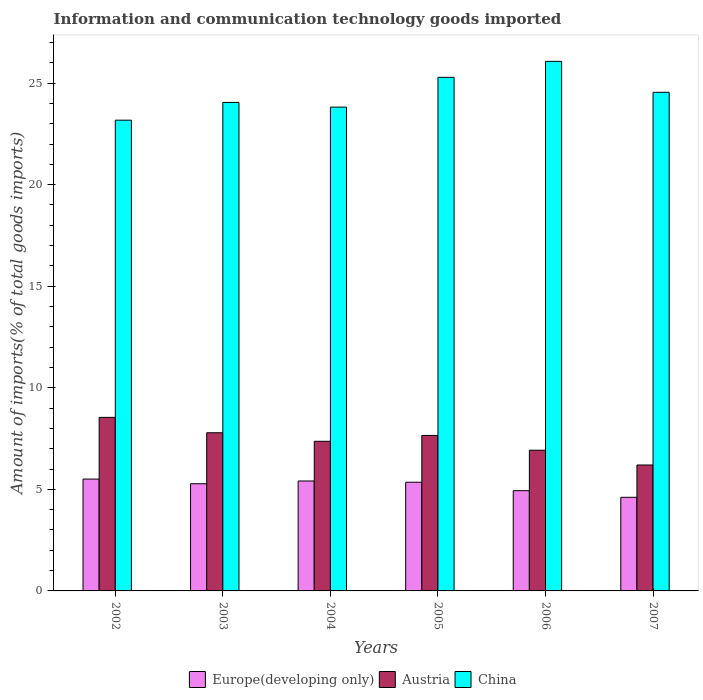How many different coloured bars are there?
Your answer should be compact. 3. How many groups of bars are there?
Your response must be concise. 6. In how many cases, is the number of bars for a given year not equal to the number of legend labels?
Offer a very short reply. 0. What is the amount of goods imported in China in 2006?
Give a very brief answer. 26.07. Across all years, what is the maximum amount of goods imported in Austria?
Offer a terse response. 8.54. Across all years, what is the minimum amount of goods imported in China?
Give a very brief answer. 23.17. In which year was the amount of goods imported in Austria maximum?
Offer a very short reply. 2002. What is the total amount of goods imported in Europe(developing only) in the graph?
Offer a very short reply. 31.09. What is the difference between the amount of goods imported in Austria in 2002 and that in 2005?
Provide a short and direct response. 0.89. What is the difference between the amount of goods imported in Austria in 2006 and the amount of goods imported in Europe(developing only) in 2004?
Your response must be concise. 1.51. What is the average amount of goods imported in China per year?
Your answer should be compact. 24.49. In the year 2005, what is the difference between the amount of goods imported in Austria and amount of goods imported in Europe(developing only)?
Offer a very short reply. 2.3. What is the ratio of the amount of goods imported in China in 2002 to that in 2007?
Keep it short and to the point. 0.94. Is the amount of goods imported in China in 2004 less than that in 2005?
Provide a succinct answer. Yes. What is the difference between the highest and the second highest amount of goods imported in Europe(developing only)?
Give a very brief answer. 0.09. What is the difference between the highest and the lowest amount of goods imported in China?
Make the answer very short. 2.9. Is the sum of the amount of goods imported in China in 2003 and 2004 greater than the maximum amount of goods imported in Austria across all years?
Offer a terse response. Yes. What does the 3rd bar from the left in 2005 represents?
Give a very brief answer. China. How many bars are there?
Provide a short and direct response. 18. Where does the legend appear in the graph?
Provide a succinct answer. Bottom center. How many legend labels are there?
Your answer should be compact. 3. How are the legend labels stacked?
Keep it short and to the point. Horizontal. What is the title of the graph?
Give a very brief answer. Information and communication technology goods imported. What is the label or title of the Y-axis?
Your answer should be very brief. Amount of imports(% of total goods imports). What is the Amount of imports(% of total goods imports) in Europe(developing only) in 2002?
Provide a succinct answer. 5.51. What is the Amount of imports(% of total goods imports) in Austria in 2002?
Offer a very short reply. 8.54. What is the Amount of imports(% of total goods imports) of China in 2002?
Keep it short and to the point. 23.17. What is the Amount of imports(% of total goods imports) of Europe(developing only) in 2003?
Provide a succinct answer. 5.28. What is the Amount of imports(% of total goods imports) in Austria in 2003?
Offer a very short reply. 7.79. What is the Amount of imports(% of total goods imports) in China in 2003?
Provide a short and direct response. 24.05. What is the Amount of imports(% of total goods imports) in Europe(developing only) in 2004?
Provide a short and direct response. 5.41. What is the Amount of imports(% of total goods imports) of Austria in 2004?
Make the answer very short. 7.37. What is the Amount of imports(% of total goods imports) in China in 2004?
Your answer should be compact. 23.82. What is the Amount of imports(% of total goods imports) in Europe(developing only) in 2005?
Make the answer very short. 5.35. What is the Amount of imports(% of total goods imports) in Austria in 2005?
Your answer should be compact. 7.65. What is the Amount of imports(% of total goods imports) in China in 2005?
Ensure brevity in your answer.  25.28. What is the Amount of imports(% of total goods imports) in Europe(developing only) in 2006?
Provide a short and direct response. 4.93. What is the Amount of imports(% of total goods imports) of Austria in 2006?
Offer a terse response. 6.93. What is the Amount of imports(% of total goods imports) of China in 2006?
Make the answer very short. 26.07. What is the Amount of imports(% of total goods imports) in Europe(developing only) in 2007?
Ensure brevity in your answer.  4.61. What is the Amount of imports(% of total goods imports) in Austria in 2007?
Your response must be concise. 6.2. What is the Amount of imports(% of total goods imports) of China in 2007?
Provide a succinct answer. 24.55. Across all years, what is the maximum Amount of imports(% of total goods imports) of Europe(developing only)?
Your response must be concise. 5.51. Across all years, what is the maximum Amount of imports(% of total goods imports) of Austria?
Ensure brevity in your answer.  8.54. Across all years, what is the maximum Amount of imports(% of total goods imports) of China?
Provide a short and direct response. 26.07. Across all years, what is the minimum Amount of imports(% of total goods imports) of Europe(developing only)?
Your response must be concise. 4.61. Across all years, what is the minimum Amount of imports(% of total goods imports) of Austria?
Keep it short and to the point. 6.2. Across all years, what is the minimum Amount of imports(% of total goods imports) of China?
Your answer should be compact. 23.17. What is the total Amount of imports(% of total goods imports) of Europe(developing only) in the graph?
Your answer should be compact. 31.09. What is the total Amount of imports(% of total goods imports) of Austria in the graph?
Provide a short and direct response. 44.47. What is the total Amount of imports(% of total goods imports) of China in the graph?
Keep it short and to the point. 146.93. What is the difference between the Amount of imports(% of total goods imports) in Europe(developing only) in 2002 and that in 2003?
Offer a terse response. 0.23. What is the difference between the Amount of imports(% of total goods imports) in Austria in 2002 and that in 2003?
Give a very brief answer. 0.76. What is the difference between the Amount of imports(% of total goods imports) of China in 2002 and that in 2003?
Give a very brief answer. -0.87. What is the difference between the Amount of imports(% of total goods imports) in Europe(developing only) in 2002 and that in 2004?
Offer a very short reply. 0.09. What is the difference between the Amount of imports(% of total goods imports) in Austria in 2002 and that in 2004?
Make the answer very short. 1.18. What is the difference between the Amount of imports(% of total goods imports) of China in 2002 and that in 2004?
Make the answer very short. -0.64. What is the difference between the Amount of imports(% of total goods imports) of Europe(developing only) in 2002 and that in 2005?
Keep it short and to the point. 0.16. What is the difference between the Amount of imports(% of total goods imports) in Austria in 2002 and that in 2005?
Provide a short and direct response. 0.89. What is the difference between the Amount of imports(% of total goods imports) of China in 2002 and that in 2005?
Offer a very short reply. -2.11. What is the difference between the Amount of imports(% of total goods imports) of Europe(developing only) in 2002 and that in 2006?
Give a very brief answer. 0.57. What is the difference between the Amount of imports(% of total goods imports) in Austria in 2002 and that in 2006?
Your answer should be compact. 1.62. What is the difference between the Amount of imports(% of total goods imports) in China in 2002 and that in 2006?
Offer a terse response. -2.9. What is the difference between the Amount of imports(% of total goods imports) in Europe(developing only) in 2002 and that in 2007?
Offer a terse response. 0.9. What is the difference between the Amount of imports(% of total goods imports) in Austria in 2002 and that in 2007?
Offer a terse response. 2.34. What is the difference between the Amount of imports(% of total goods imports) in China in 2002 and that in 2007?
Make the answer very short. -1.37. What is the difference between the Amount of imports(% of total goods imports) in Europe(developing only) in 2003 and that in 2004?
Offer a terse response. -0.14. What is the difference between the Amount of imports(% of total goods imports) in Austria in 2003 and that in 2004?
Keep it short and to the point. 0.42. What is the difference between the Amount of imports(% of total goods imports) in China in 2003 and that in 2004?
Offer a terse response. 0.23. What is the difference between the Amount of imports(% of total goods imports) of Europe(developing only) in 2003 and that in 2005?
Offer a terse response. -0.07. What is the difference between the Amount of imports(% of total goods imports) in Austria in 2003 and that in 2005?
Offer a very short reply. 0.13. What is the difference between the Amount of imports(% of total goods imports) in China in 2003 and that in 2005?
Keep it short and to the point. -1.24. What is the difference between the Amount of imports(% of total goods imports) of Europe(developing only) in 2003 and that in 2006?
Make the answer very short. 0.34. What is the difference between the Amount of imports(% of total goods imports) of Austria in 2003 and that in 2006?
Ensure brevity in your answer.  0.86. What is the difference between the Amount of imports(% of total goods imports) in China in 2003 and that in 2006?
Provide a succinct answer. -2.02. What is the difference between the Amount of imports(% of total goods imports) of Europe(developing only) in 2003 and that in 2007?
Offer a terse response. 0.67. What is the difference between the Amount of imports(% of total goods imports) of Austria in 2003 and that in 2007?
Your answer should be compact. 1.59. What is the difference between the Amount of imports(% of total goods imports) in China in 2003 and that in 2007?
Provide a short and direct response. -0.5. What is the difference between the Amount of imports(% of total goods imports) in Europe(developing only) in 2004 and that in 2005?
Make the answer very short. 0.06. What is the difference between the Amount of imports(% of total goods imports) in Austria in 2004 and that in 2005?
Ensure brevity in your answer.  -0.29. What is the difference between the Amount of imports(% of total goods imports) in China in 2004 and that in 2005?
Your answer should be very brief. -1.47. What is the difference between the Amount of imports(% of total goods imports) of Europe(developing only) in 2004 and that in 2006?
Offer a terse response. 0.48. What is the difference between the Amount of imports(% of total goods imports) in Austria in 2004 and that in 2006?
Provide a succinct answer. 0.44. What is the difference between the Amount of imports(% of total goods imports) of China in 2004 and that in 2006?
Provide a succinct answer. -2.25. What is the difference between the Amount of imports(% of total goods imports) of Europe(developing only) in 2004 and that in 2007?
Your answer should be very brief. 0.8. What is the difference between the Amount of imports(% of total goods imports) of Austria in 2004 and that in 2007?
Offer a very short reply. 1.17. What is the difference between the Amount of imports(% of total goods imports) of China in 2004 and that in 2007?
Ensure brevity in your answer.  -0.73. What is the difference between the Amount of imports(% of total goods imports) in Europe(developing only) in 2005 and that in 2006?
Your response must be concise. 0.42. What is the difference between the Amount of imports(% of total goods imports) of Austria in 2005 and that in 2006?
Provide a succinct answer. 0.73. What is the difference between the Amount of imports(% of total goods imports) of China in 2005 and that in 2006?
Your answer should be very brief. -0.79. What is the difference between the Amount of imports(% of total goods imports) in Europe(developing only) in 2005 and that in 2007?
Give a very brief answer. 0.74. What is the difference between the Amount of imports(% of total goods imports) of Austria in 2005 and that in 2007?
Your answer should be compact. 1.46. What is the difference between the Amount of imports(% of total goods imports) of China in 2005 and that in 2007?
Your answer should be compact. 0.74. What is the difference between the Amount of imports(% of total goods imports) of Europe(developing only) in 2006 and that in 2007?
Offer a very short reply. 0.33. What is the difference between the Amount of imports(% of total goods imports) in Austria in 2006 and that in 2007?
Your response must be concise. 0.73. What is the difference between the Amount of imports(% of total goods imports) in China in 2006 and that in 2007?
Offer a very short reply. 1.52. What is the difference between the Amount of imports(% of total goods imports) in Europe(developing only) in 2002 and the Amount of imports(% of total goods imports) in Austria in 2003?
Provide a succinct answer. -2.28. What is the difference between the Amount of imports(% of total goods imports) of Europe(developing only) in 2002 and the Amount of imports(% of total goods imports) of China in 2003?
Ensure brevity in your answer.  -18.54. What is the difference between the Amount of imports(% of total goods imports) in Austria in 2002 and the Amount of imports(% of total goods imports) in China in 2003?
Give a very brief answer. -15.5. What is the difference between the Amount of imports(% of total goods imports) in Europe(developing only) in 2002 and the Amount of imports(% of total goods imports) in Austria in 2004?
Your answer should be very brief. -1.86. What is the difference between the Amount of imports(% of total goods imports) in Europe(developing only) in 2002 and the Amount of imports(% of total goods imports) in China in 2004?
Your answer should be very brief. -18.31. What is the difference between the Amount of imports(% of total goods imports) of Austria in 2002 and the Amount of imports(% of total goods imports) of China in 2004?
Keep it short and to the point. -15.27. What is the difference between the Amount of imports(% of total goods imports) in Europe(developing only) in 2002 and the Amount of imports(% of total goods imports) in Austria in 2005?
Your answer should be very brief. -2.15. What is the difference between the Amount of imports(% of total goods imports) in Europe(developing only) in 2002 and the Amount of imports(% of total goods imports) in China in 2005?
Provide a short and direct response. -19.78. What is the difference between the Amount of imports(% of total goods imports) in Austria in 2002 and the Amount of imports(% of total goods imports) in China in 2005?
Keep it short and to the point. -16.74. What is the difference between the Amount of imports(% of total goods imports) in Europe(developing only) in 2002 and the Amount of imports(% of total goods imports) in Austria in 2006?
Give a very brief answer. -1.42. What is the difference between the Amount of imports(% of total goods imports) of Europe(developing only) in 2002 and the Amount of imports(% of total goods imports) of China in 2006?
Provide a short and direct response. -20.56. What is the difference between the Amount of imports(% of total goods imports) of Austria in 2002 and the Amount of imports(% of total goods imports) of China in 2006?
Keep it short and to the point. -17.53. What is the difference between the Amount of imports(% of total goods imports) in Europe(developing only) in 2002 and the Amount of imports(% of total goods imports) in Austria in 2007?
Your answer should be very brief. -0.69. What is the difference between the Amount of imports(% of total goods imports) of Europe(developing only) in 2002 and the Amount of imports(% of total goods imports) of China in 2007?
Your answer should be compact. -19.04. What is the difference between the Amount of imports(% of total goods imports) in Austria in 2002 and the Amount of imports(% of total goods imports) in China in 2007?
Your answer should be very brief. -16. What is the difference between the Amount of imports(% of total goods imports) of Europe(developing only) in 2003 and the Amount of imports(% of total goods imports) of Austria in 2004?
Give a very brief answer. -2.09. What is the difference between the Amount of imports(% of total goods imports) of Europe(developing only) in 2003 and the Amount of imports(% of total goods imports) of China in 2004?
Offer a terse response. -18.54. What is the difference between the Amount of imports(% of total goods imports) in Austria in 2003 and the Amount of imports(% of total goods imports) in China in 2004?
Offer a terse response. -16.03. What is the difference between the Amount of imports(% of total goods imports) in Europe(developing only) in 2003 and the Amount of imports(% of total goods imports) in Austria in 2005?
Keep it short and to the point. -2.38. What is the difference between the Amount of imports(% of total goods imports) of Europe(developing only) in 2003 and the Amount of imports(% of total goods imports) of China in 2005?
Your response must be concise. -20.01. What is the difference between the Amount of imports(% of total goods imports) of Austria in 2003 and the Amount of imports(% of total goods imports) of China in 2005?
Your response must be concise. -17.5. What is the difference between the Amount of imports(% of total goods imports) of Europe(developing only) in 2003 and the Amount of imports(% of total goods imports) of Austria in 2006?
Give a very brief answer. -1.65. What is the difference between the Amount of imports(% of total goods imports) in Europe(developing only) in 2003 and the Amount of imports(% of total goods imports) in China in 2006?
Give a very brief answer. -20.79. What is the difference between the Amount of imports(% of total goods imports) in Austria in 2003 and the Amount of imports(% of total goods imports) in China in 2006?
Offer a very short reply. -18.28. What is the difference between the Amount of imports(% of total goods imports) in Europe(developing only) in 2003 and the Amount of imports(% of total goods imports) in Austria in 2007?
Your answer should be compact. -0.92. What is the difference between the Amount of imports(% of total goods imports) of Europe(developing only) in 2003 and the Amount of imports(% of total goods imports) of China in 2007?
Offer a terse response. -19.27. What is the difference between the Amount of imports(% of total goods imports) of Austria in 2003 and the Amount of imports(% of total goods imports) of China in 2007?
Give a very brief answer. -16.76. What is the difference between the Amount of imports(% of total goods imports) in Europe(developing only) in 2004 and the Amount of imports(% of total goods imports) in Austria in 2005?
Make the answer very short. -2.24. What is the difference between the Amount of imports(% of total goods imports) in Europe(developing only) in 2004 and the Amount of imports(% of total goods imports) in China in 2005?
Give a very brief answer. -19.87. What is the difference between the Amount of imports(% of total goods imports) of Austria in 2004 and the Amount of imports(% of total goods imports) of China in 2005?
Your response must be concise. -17.92. What is the difference between the Amount of imports(% of total goods imports) in Europe(developing only) in 2004 and the Amount of imports(% of total goods imports) in Austria in 2006?
Ensure brevity in your answer.  -1.51. What is the difference between the Amount of imports(% of total goods imports) of Europe(developing only) in 2004 and the Amount of imports(% of total goods imports) of China in 2006?
Ensure brevity in your answer.  -20.66. What is the difference between the Amount of imports(% of total goods imports) in Austria in 2004 and the Amount of imports(% of total goods imports) in China in 2006?
Give a very brief answer. -18.7. What is the difference between the Amount of imports(% of total goods imports) of Europe(developing only) in 2004 and the Amount of imports(% of total goods imports) of Austria in 2007?
Your answer should be compact. -0.79. What is the difference between the Amount of imports(% of total goods imports) of Europe(developing only) in 2004 and the Amount of imports(% of total goods imports) of China in 2007?
Make the answer very short. -19.13. What is the difference between the Amount of imports(% of total goods imports) in Austria in 2004 and the Amount of imports(% of total goods imports) in China in 2007?
Offer a terse response. -17.18. What is the difference between the Amount of imports(% of total goods imports) of Europe(developing only) in 2005 and the Amount of imports(% of total goods imports) of Austria in 2006?
Offer a very short reply. -1.58. What is the difference between the Amount of imports(% of total goods imports) in Europe(developing only) in 2005 and the Amount of imports(% of total goods imports) in China in 2006?
Your answer should be very brief. -20.72. What is the difference between the Amount of imports(% of total goods imports) of Austria in 2005 and the Amount of imports(% of total goods imports) of China in 2006?
Ensure brevity in your answer.  -18.41. What is the difference between the Amount of imports(% of total goods imports) of Europe(developing only) in 2005 and the Amount of imports(% of total goods imports) of Austria in 2007?
Keep it short and to the point. -0.85. What is the difference between the Amount of imports(% of total goods imports) of Europe(developing only) in 2005 and the Amount of imports(% of total goods imports) of China in 2007?
Your answer should be very brief. -19.2. What is the difference between the Amount of imports(% of total goods imports) in Austria in 2005 and the Amount of imports(% of total goods imports) in China in 2007?
Ensure brevity in your answer.  -16.89. What is the difference between the Amount of imports(% of total goods imports) of Europe(developing only) in 2006 and the Amount of imports(% of total goods imports) of Austria in 2007?
Give a very brief answer. -1.26. What is the difference between the Amount of imports(% of total goods imports) in Europe(developing only) in 2006 and the Amount of imports(% of total goods imports) in China in 2007?
Provide a short and direct response. -19.61. What is the difference between the Amount of imports(% of total goods imports) of Austria in 2006 and the Amount of imports(% of total goods imports) of China in 2007?
Ensure brevity in your answer.  -17.62. What is the average Amount of imports(% of total goods imports) in Europe(developing only) per year?
Offer a terse response. 5.18. What is the average Amount of imports(% of total goods imports) of Austria per year?
Give a very brief answer. 7.41. What is the average Amount of imports(% of total goods imports) in China per year?
Your answer should be very brief. 24.49. In the year 2002, what is the difference between the Amount of imports(% of total goods imports) of Europe(developing only) and Amount of imports(% of total goods imports) of Austria?
Offer a terse response. -3.04. In the year 2002, what is the difference between the Amount of imports(% of total goods imports) of Europe(developing only) and Amount of imports(% of total goods imports) of China?
Your response must be concise. -17.67. In the year 2002, what is the difference between the Amount of imports(% of total goods imports) in Austria and Amount of imports(% of total goods imports) in China?
Offer a terse response. -14.63. In the year 2003, what is the difference between the Amount of imports(% of total goods imports) of Europe(developing only) and Amount of imports(% of total goods imports) of Austria?
Your answer should be very brief. -2.51. In the year 2003, what is the difference between the Amount of imports(% of total goods imports) in Europe(developing only) and Amount of imports(% of total goods imports) in China?
Your answer should be very brief. -18.77. In the year 2003, what is the difference between the Amount of imports(% of total goods imports) in Austria and Amount of imports(% of total goods imports) in China?
Offer a very short reply. -16.26. In the year 2004, what is the difference between the Amount of imports(% of total goods imports) in Europe(developing only) and Amount of imports(% of total goods imports) in Austria?
Make the answer very short. -1.95. In the year 2004, what is the difference between the Amount of imports(% of total goods imports) in Europe(developing only) and Amount of imports(% of total goods imports) in China?
Give a very brief answer. -18.4. In the year 2004, what is the difference between the Amount of imports(% of total goods imports) of Austria and Amount of imports(% of total goods imports) of China?
Your answer should be compact. -16.45. In the year 2005, what is the difference between the Amount of imports(% of total goods imports) in Europe(developing only) and Amount of imports(% of total goods imports) in Austria?
Make the answer very short. -2.3. In the year 2005, what is the difference between the Amount of imports(% of total goods imports) in Europe(developing only) and Amount of imports(% of total goods imports) in China?
Provide a short and direct response. -19.93. In the year 2005, what is the difference between the Amount of imports(% of total goods imports) in Austria and Amount of imports(% of total goods imports) in China?
Provide a short and direct response. -17.63. In the year 2006, what is the difference between the Amount of imports(% of total goods imports) of Europe(developing only) and Amount of imports(% of total goods imports) of Austria?
Provide a succinct answer. -1.99. In the year 2006, what is the difference between the Amount of imports(% of total goods imports) in Europe(developing only) and Amount of imports(% of total goods imports) in China?
Provide a succinct answer. -21.13. In the year 2006, what is the difference between the Amount of imports(% of total goods imports) of Austria and Amount of imports(% of total goods imports) of China?
Ensure brevity in your answer.  -19.14. In the year 2007, what is the difference between the Amount of imports(% of total goods imports) in Europe(developing only) and Amount of imports(% of total goods imports) in Austria?
Your answer should be compact. -1.59. In the year 2007, what is the difference between the Amount of imports(% of total goods imports) of Europe(developing only) and Amount of imports(% of total goods imports) of China?
Keep it short and to the point. -19.94. In the year 2007, what is the difference between the Amount of imports(% of total goods imports) of Austria and Amount of imports(% of total goods imports) of China?
Offer a very short reply. -18.35. What is the ratio of the Amount of imports(% of total goods imports) in Europe(developing only) in 2002 to that in 2003?
Your answer should be very brief. 1.04. What is the ratio of the Amount of imports(% of total goods imports) in Austria in 2002 to that in 2003?
Keep it short and to the point. 1.1. What is the ratio of the Amount of imports(% of total goods imports) of China in 2002 to that in 2003?
Offer a terse response. 0.96. What is the ratio of the Amount of imports(% of total goods imports) in Europe(developing only) in 2002 to that in 2004?
Your answer should be very brief. 1.02. What is the ratio of the Amount of imports(% of total goods imports) in Austria in 2002 to that in 2004?
Offer a very short reply. 1.16. What is the ratio of the Amount of imports(% of total goods imports) of China in 2002 to that in 2004?
Your response must be concise. 0.97. What is the ratio of the Amount of imports(% of total goods imports) in Europe(developing only) in 2002 to that in 2005?
Your response must be concise. 1.03. What is the ratio of the Amount of imports(% of total goods imports) of Austria in 2002 to that in 2005?
Provide a succinct answer. 1.12. What is the ratio of the Amount of imports(% of total goods imports) in China in 2002 to that in 2005?
Provide a short and direct response. 0.92. What is the ratio of the Amount of imports(% of total goods imports) of Europe(developing only) in 2002 to that in 2006?
Make the answer very short. 1.12. What is the ratio of the Amount of imports(% of total goods imports) in Austria in 2002 to that in 2006?
Ensure brevity in your answer.  1.23. What is the ratio of the Amount of imports(% of total goods imports) of Europe(developing only) in 2002 to that in 2007?
Give a very brief answer. 1.19. What is the ratio of the Amount of imports(% of total goods imports) of Austria in 2002 to that in 2007?
Your answer should be very brief. 1.38. What is the ratio of the Amount of imports(% of total goods imports) of China in 2002 to that in 2007?
Your answer should be very brief. 0.94. What is the ratio of the Amount of imports(% of total goods imports) of Europe(developing only) in 2003 to that in 2004?
Offer a very short reply. 0.97. What is the ratio of the Amount of imports(% of total goods imports) of Austria in 2003 to that in 2004?
Offer a terse response. 1.06. What is the ratio of the Amount of imports(% of total goods imports) in China in 2003 to that in 2004?
Give a very brief answer. 1.01. What is the ratio of the Amount of imports(% of total goods imports) in Europe(developing only) in 2003 to that in 2005?
Provide a succinct answer. 0.99. What is the ratio of the Amount of imports(% of total goods imports) of Austria in 2003 to that in 2005?
Ensure brevity in your answer.  1.02. What is the ratio of the Amount of imports(% of total goods imports) in China in 2003 to that in 2005?
Your response must be concise. 0.95. What is the ratio of the Amount of imports(% of total goods imports) of Europe(developing only) in 2003 to that in 2006?
Provide a short and direct response. 1.07. What is the ratio of the Amount of imports(% of total goods imports) in Austria in 2003 to that in 2006?
Keep it short and to the point. 1.12. What is the ratio of the Amount of imports(% of total goods imports) of China in 2003 to that in 2006?
Your answer should be compact. 0.92. What is the ratio of the Amount of imports(% of total goods imports) of Europe(developing only) in 2003 to that in 2007?
Provide a short and direct response. 1.15. What is the ratio of the Amount of imports(% of total goods imports) of Austria in 2003 to that in 2007?
Offer a terse response. 1.26. What is the ratio of the Amount of imports(% of total goods imports) of China in 2003 to that in 2007?
Your answer should be compact. 0.98. What is the ratio of the Amount of imports(% of total goods imports) in Europe(developing only) in 2004 to that in 2005?
Offer a terse response. 1.01. What is the ratio of the Amount of imports(% of total goods imports) in Austria in 2004 to that in 2005?
Offer a terse response. 0.96. What is the ratio of the Amount of imports(% of total goods imports) of China in 2004 to that in 2005?
Offer a terse response. 0.94. What is the ratio of the Amount of imports(% of total goods imports) of Europe(developing only) in 2004 to that in 2006?
Offer a terse response. 1.1. What is the ratio of the Amount of imports(% of total goods imports) of Austria in 2004 to that in 2006?
Give a very brief answer. 1.06. What is the ratio of the Amount of imports(% of total goods imports) in China in 2004 to that in 2006?
Keep it short and to the point. 0.91. What is the ratio of the Amount of imports(% of total goods imports) in Europe(developing only) in 2004 to that in 2007?
Offer a terse response. 1.17. What is the ratio of the Amount of imports(% of total goods imports) of Austria in 2004 to that in 2007?
Give a very brief answer. 1.19. What is the ratio of the Amount of imports(% of total goods imports) of China in 2004 to that in 2007?
Ensure brevity in your answer.  0.97. What is the ratio of the Amount of imports(% of total goods imports) of Europe(developing only) in 2005 to that in 2006?
Offer a very short reply. 1.08. What is the ratio of the Amount of imports(% of total goods imports) in Austria in 2005 to that in 2006?
Your answer should be compact. 1.11. What is the ratio of the Amount of imports(% of total goods imports) of China in 2005 to that in 2006?
Your answer should be compact. 0.97. What is the ratio of the Amount of imports(% of total goods imports) in Europe(developing only) in 2005 to that in 2007?
Provide a succinct answer. 1.16. What is the ratio of the Amount of imports(% of total goods imports) of Austria in 2005 to that in 2007?
Provide a succinct answer. 1.23. What is the ratio of the Amount of imports(% of total goods imports) in Europe(developing only) in 2006 to that in 2007?
Provide a succinct answer. 1.07. What is the ratio of the Amount of imports(% of total goods imports) in Austria in 2006 to that in 2007?
Offer a very short reply. 1.12. What is the ratio of the Amount of imports(% of total goods imports) of China in 2006 to that in 2007?
Make the answer very short. 1.06. What is the difference between the highest and the second highest Amount of imports(% of total goods imports) in Europe(developing only)?
Your answer should be compact. 0.09. What is the difference between the highest and the second highest Amount of imports(% of total goods imports) of Austria?
Your answer should be very brief. 0.76. What is the difference between the highest and the second highest Amount of imports(% of total goods imports) of China?
Provide a succinct answer. 0.79. What is the difference between the highest and the lowest Amount of imports(% of total goods imports) in Europe(developing only)?
Offer a terse response. 0.9. What is the difference between the highest and the lowest Amount of imports(% of total goods imports) in Austria?
Ensure brevity in your answer.  2.34. What is the difference between the highest and the lowest Amount of imports(% of total goods imports) of China?
Keep it short and to the point. 2.9. 